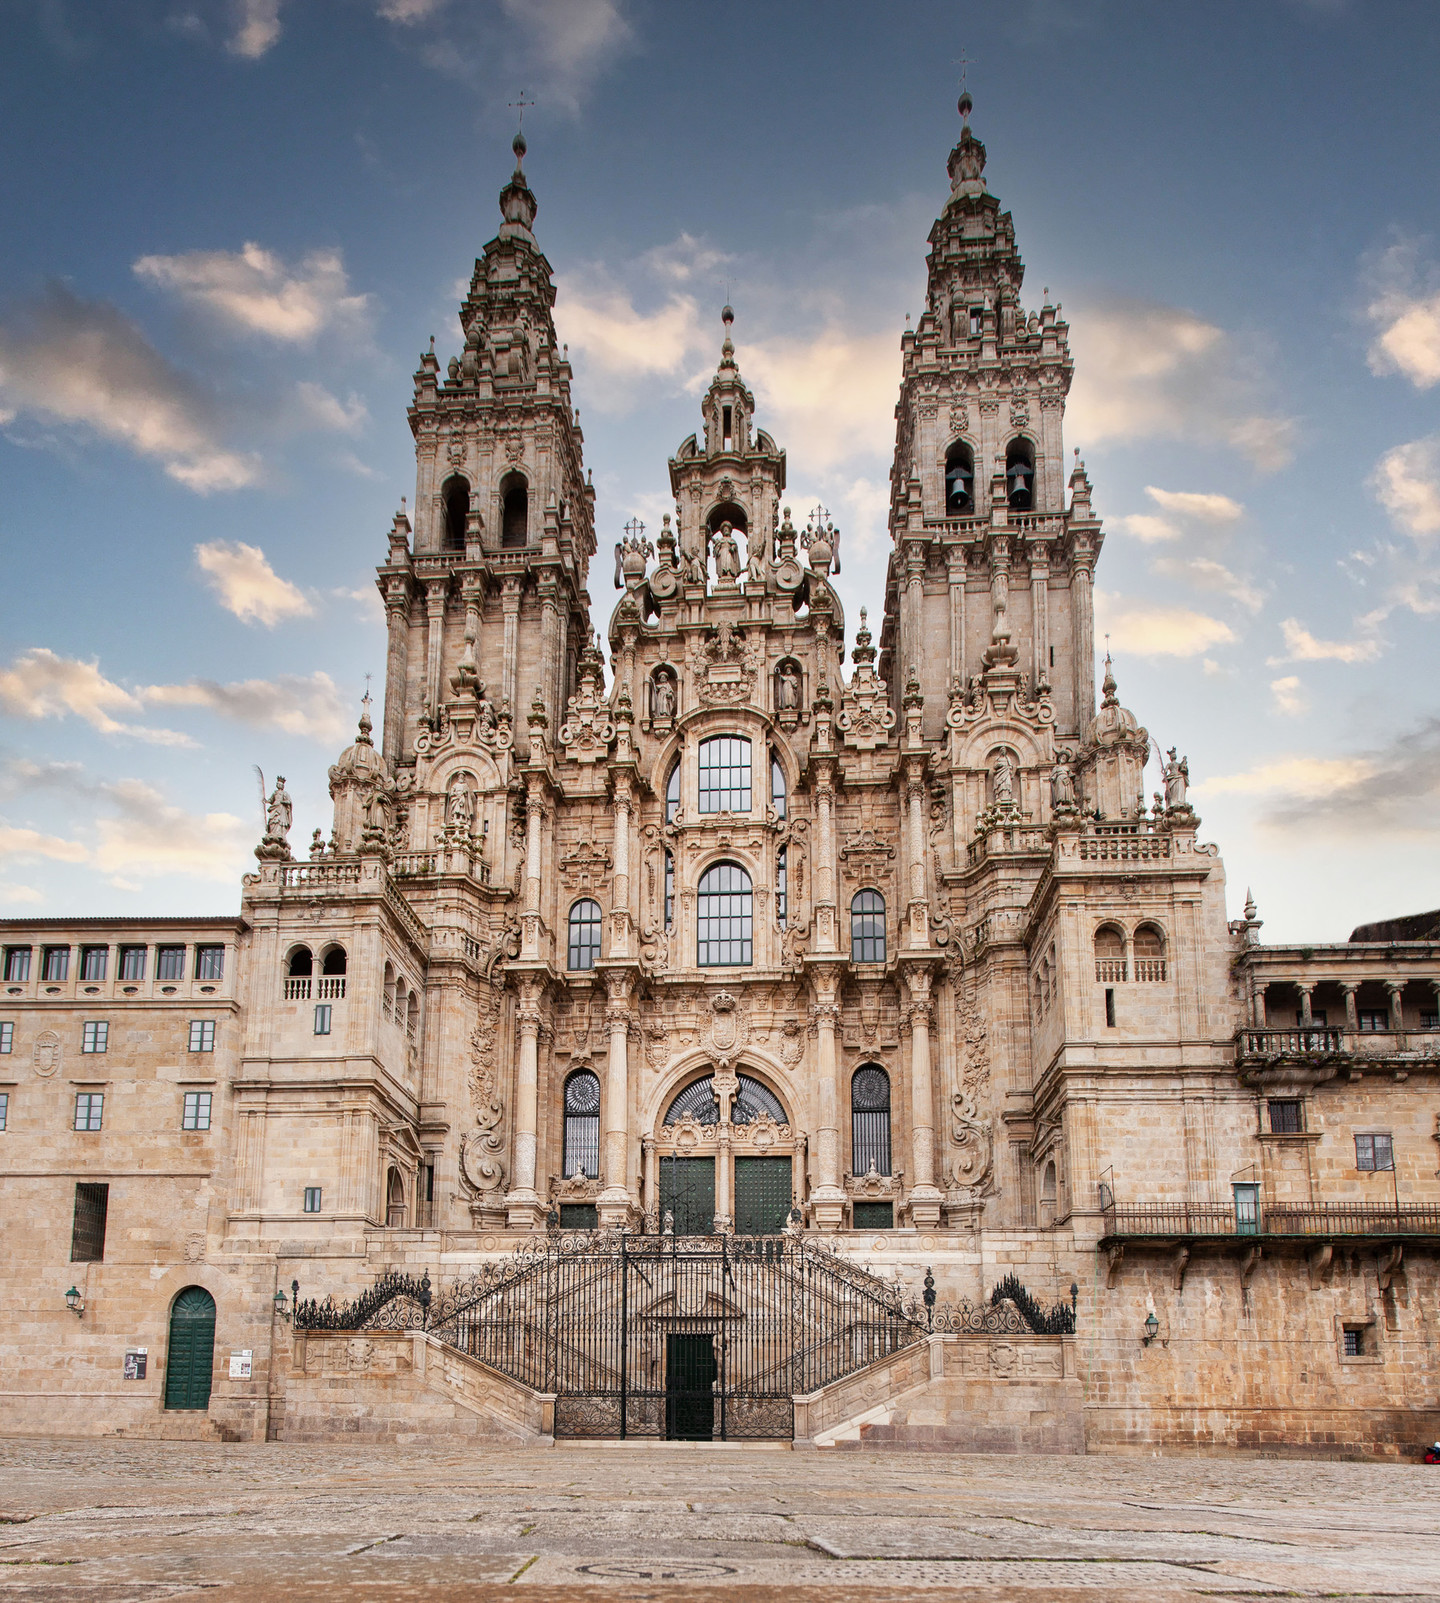What emotions does the image of this cathedral evoke? The image of the Cathedral Santiago De Compostela evokes a sense of awe and reverence. The grand and imposing structure, with its majestic spires reaching towards the sky, inspires admiration for the architectural prowess and artistic dedication involved in its construction. The intricate details and ornate carvings hold a timeless beauty that can evoke feelings of historical curiosity and a deep appreciation for cultural heritage. The serene sky in the background and the warm hues of the stone add to the tranquil yet majestic atmosphere, providing a sense of peace and contemplation. How does the cathedral's setting contribute to its overall impression? The setting of the Cathedral Santiago De Compostela significantly enhances its overall impression. Situated in the historic city of Santiago de Compostela, the cathedral is surrounded by a harmonious blend of historical architecture and cobblestone streets, which magnify its historical and cultural presence. The low-angle shot of the image captures the expansive sky above, adding a sense of openness and grandeur. The warm lighting bathes the stone facade, highlighting the intricate details and adding depth to its visual impact, making it not only an architectural marvel but also a symbol of spiritual and historical significance. If you were to write a story inspired by this image, what would it be about? In the heart of Santiago de Compostela lies the majestic cathedral, an architectural treasure that holds countless secrets and stories of pilgrims from ages past. This image would inspire a story about a young historian named Isabel who stumbles upon an ancient manuscript hidden within the cathedral's library. The manuscript hints at an undiscovered relic buried within the cathedral grounds, believed to possess divine powers. As Isabel deciphers the cryptic clues, she embarks on a thrilling adventure, navigating hidden chambers and ancient crypts, unraveling the mystery entwined with her own family history. Along her journey, she encounters unexpected allies and adversaries, uncovering the relic's true significance and the profound, transformative power it holds, not only for the faithful seekers but also for the entire world. 